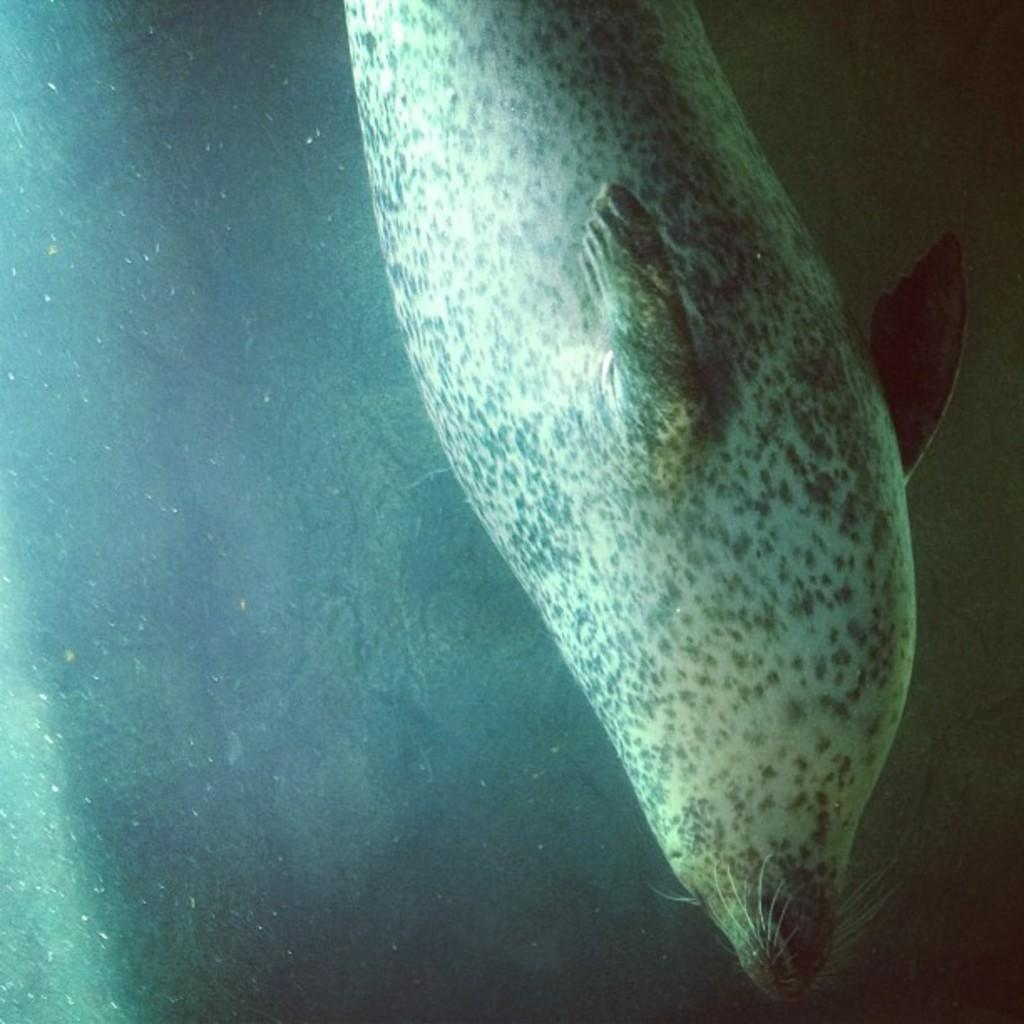What animal is in the image? There is a sea lion in the image. Where is the sea lion located? The sea lion is in the water. What instrument is the sea lion playing in the image? There is no instrument present in the image, and the sea lion is not playing any instrument. 